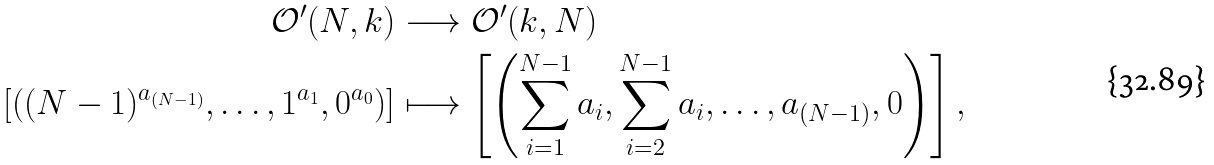<formula> <loc_0><loc_0><loc_500><loc_500>\mathcal { O } ^ { \prime } ( N , k ) & \longrightarrow \mathcal { O } ^ { \prime } ( k , N ) \\ [ ( ( N - 1 ) ^ { a _ { ( N - 1 ) } } , \dots , 1 ^ { a _ { 1 } } , 0 ^ { a _ { 0 } } ) ] & \longmapsto \left [ \left ( \sum _ { i = 1 } ^ { N - 1 } a _ { i } , \sum _ { i = 2 } ^ { N - 1 } a _ { i } , \dots , a _ { ( N - 1 ) } , 0 \right ) \right ] ,</formula> 